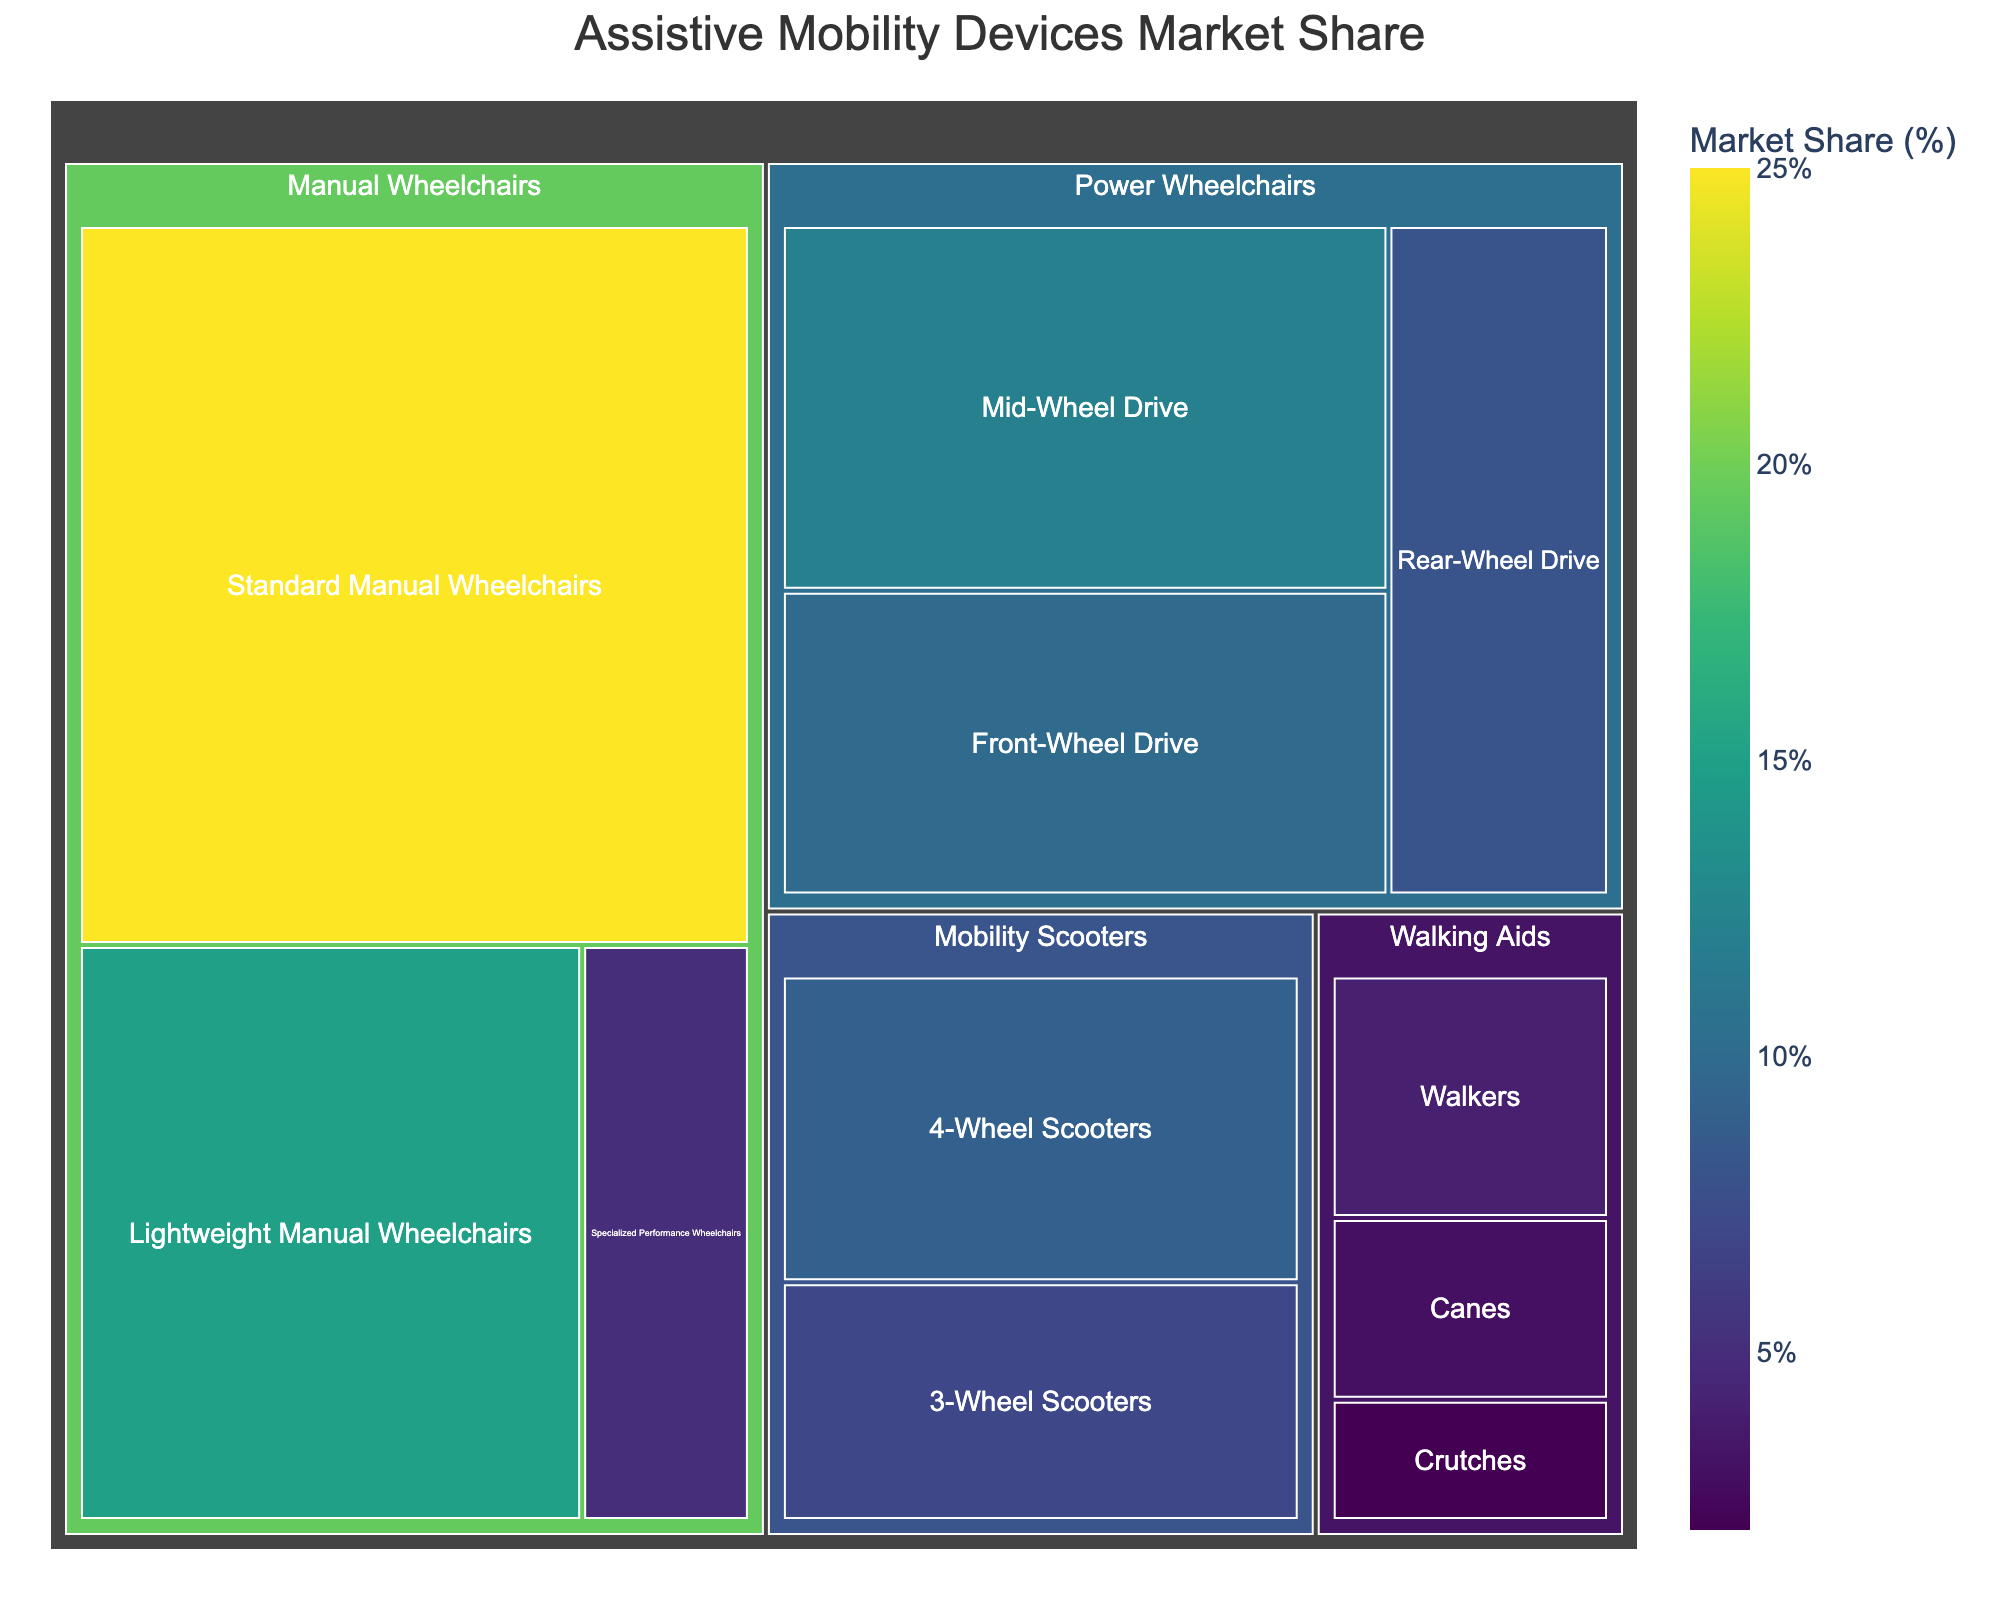Which category has the biggest market share? The largest rectangle in the treemap represents the category with the biggest market share. By visual inspection, "Manual Wheelchairs" occupy the largest area.
Answer: Manual Wheelchairs What's the combined market share of all types of Power Wheelchairs? Add up the market shares of "Front-Wheel Drive" (10%), "Mid-Wheel Drive" (12%), and "Rear-Wheel Drive" (8%) within the Power Wheelchairs category. So, 10 + 12 + 8 = 30.
Answer: 30% Which subcategory within the Power Wheelchairs has the least market share? Look at the smallest rectangle within the "Power Wheelchairs" section. The "Rear-Wheel Drive" with 8% is the smallest in this category.
Answer: Rear-Wheel Drive Are Mobility Scooters more or less popular than Walking Aids? Compare the combined market share of subcategories under "Mobility Scooters" (7% + 9% = 16%) with the "Walking Aids" (3% + 2% + 4% = 9%). Mobility Scooters have a larger combined market share.
Answer: More popular What is the difference in market share between standard manual wheelchairs and lightweight manual wheelchairs? The market share for "Standard Manual Wheelchairs" is 25% and for "Lightweight Manual Wheelchairs" is 15%. The difference is 25 - 15 = 10.
Answer: 10% Which subcategory of manual wheelchairs accounts for the smallest market share? Of the three subcategories of "Manual Wheelchairs," "Specialized Performance Wheelchairs" has the smallest market share with 5%.
Answer: Specialized Performance Wheelchairs Can you list all categories and their respective subcategories from the treemap? Treemap categories: 
- Manual Wheelchairs: Standard Manual Wheelchairs, Lightweight Manual Wheelchairs, Specialized Performance Wheelchairs
- Power Wheelchairs: Front-Wheel Drive, Mid-Wheel Drive, Rear-Wheel Drive
- Mobility Scooters: 3-Wheel Scooters, 4-Wheel Scooters
- Walking Aids: Canes, Crutches, Walkers
Answer: Manual Wheelchairs: Standard Manual Wheelchairs, Lightweight Manual Wheelchairs, Specialized Performance Wheelchairs; Power Wheelchairs: Front-Wheel Drive, Mid-Wheel Drive, Rear-Wheel Drive; Mobility Scooters: 3-Wheel Scooters, 4-Wheel Scooters; Walking Aids: Canes, Crutches, Walkers Considering only the Mobility Scooters category, which subcategory has a higher market share? Compare "3-Wheel Scooters" (7%) with "4-Wheel Scooters" (9%). The "4-Wheel Scooters" have a higher market share.
Answer: 4-Wheel Scooters What's the total market share of all categories represented in the treemap? Add up all the market shares: 25 + 15 + 5 + 10 + 12 + 8 + 7 + 9 + 3 + 2 + 4. The total is 100.
Answer: 100% What's the smallest subcategory in the entire treemap in terms of market share? By visual inspection, the smallest rectangle overall is for "Crutches" under "Walking Aids," which has a market share of 2%.
Answer: Crutches 